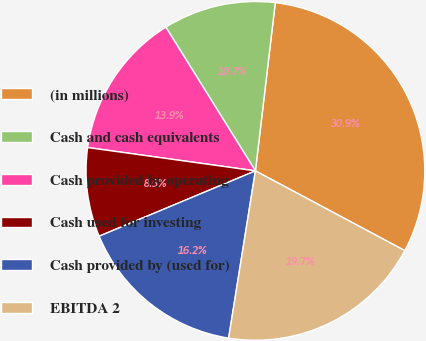<chart> <loc_0><loc_0><loc_500><loc_500><pie_chart><fcel>(in millions)<fcel>Cash and cash equivalents<fcel>Cash provided by operating<fcel>Cash used for investing<fcel>Cash provided by (used for)<fcel>EBITDA 2<nl><fcel>30.93%<fcel>10.74%<fcel>13.93%<fcel>8.5%<fcel>16.17%<fcel>19.72%<nl></chart> 